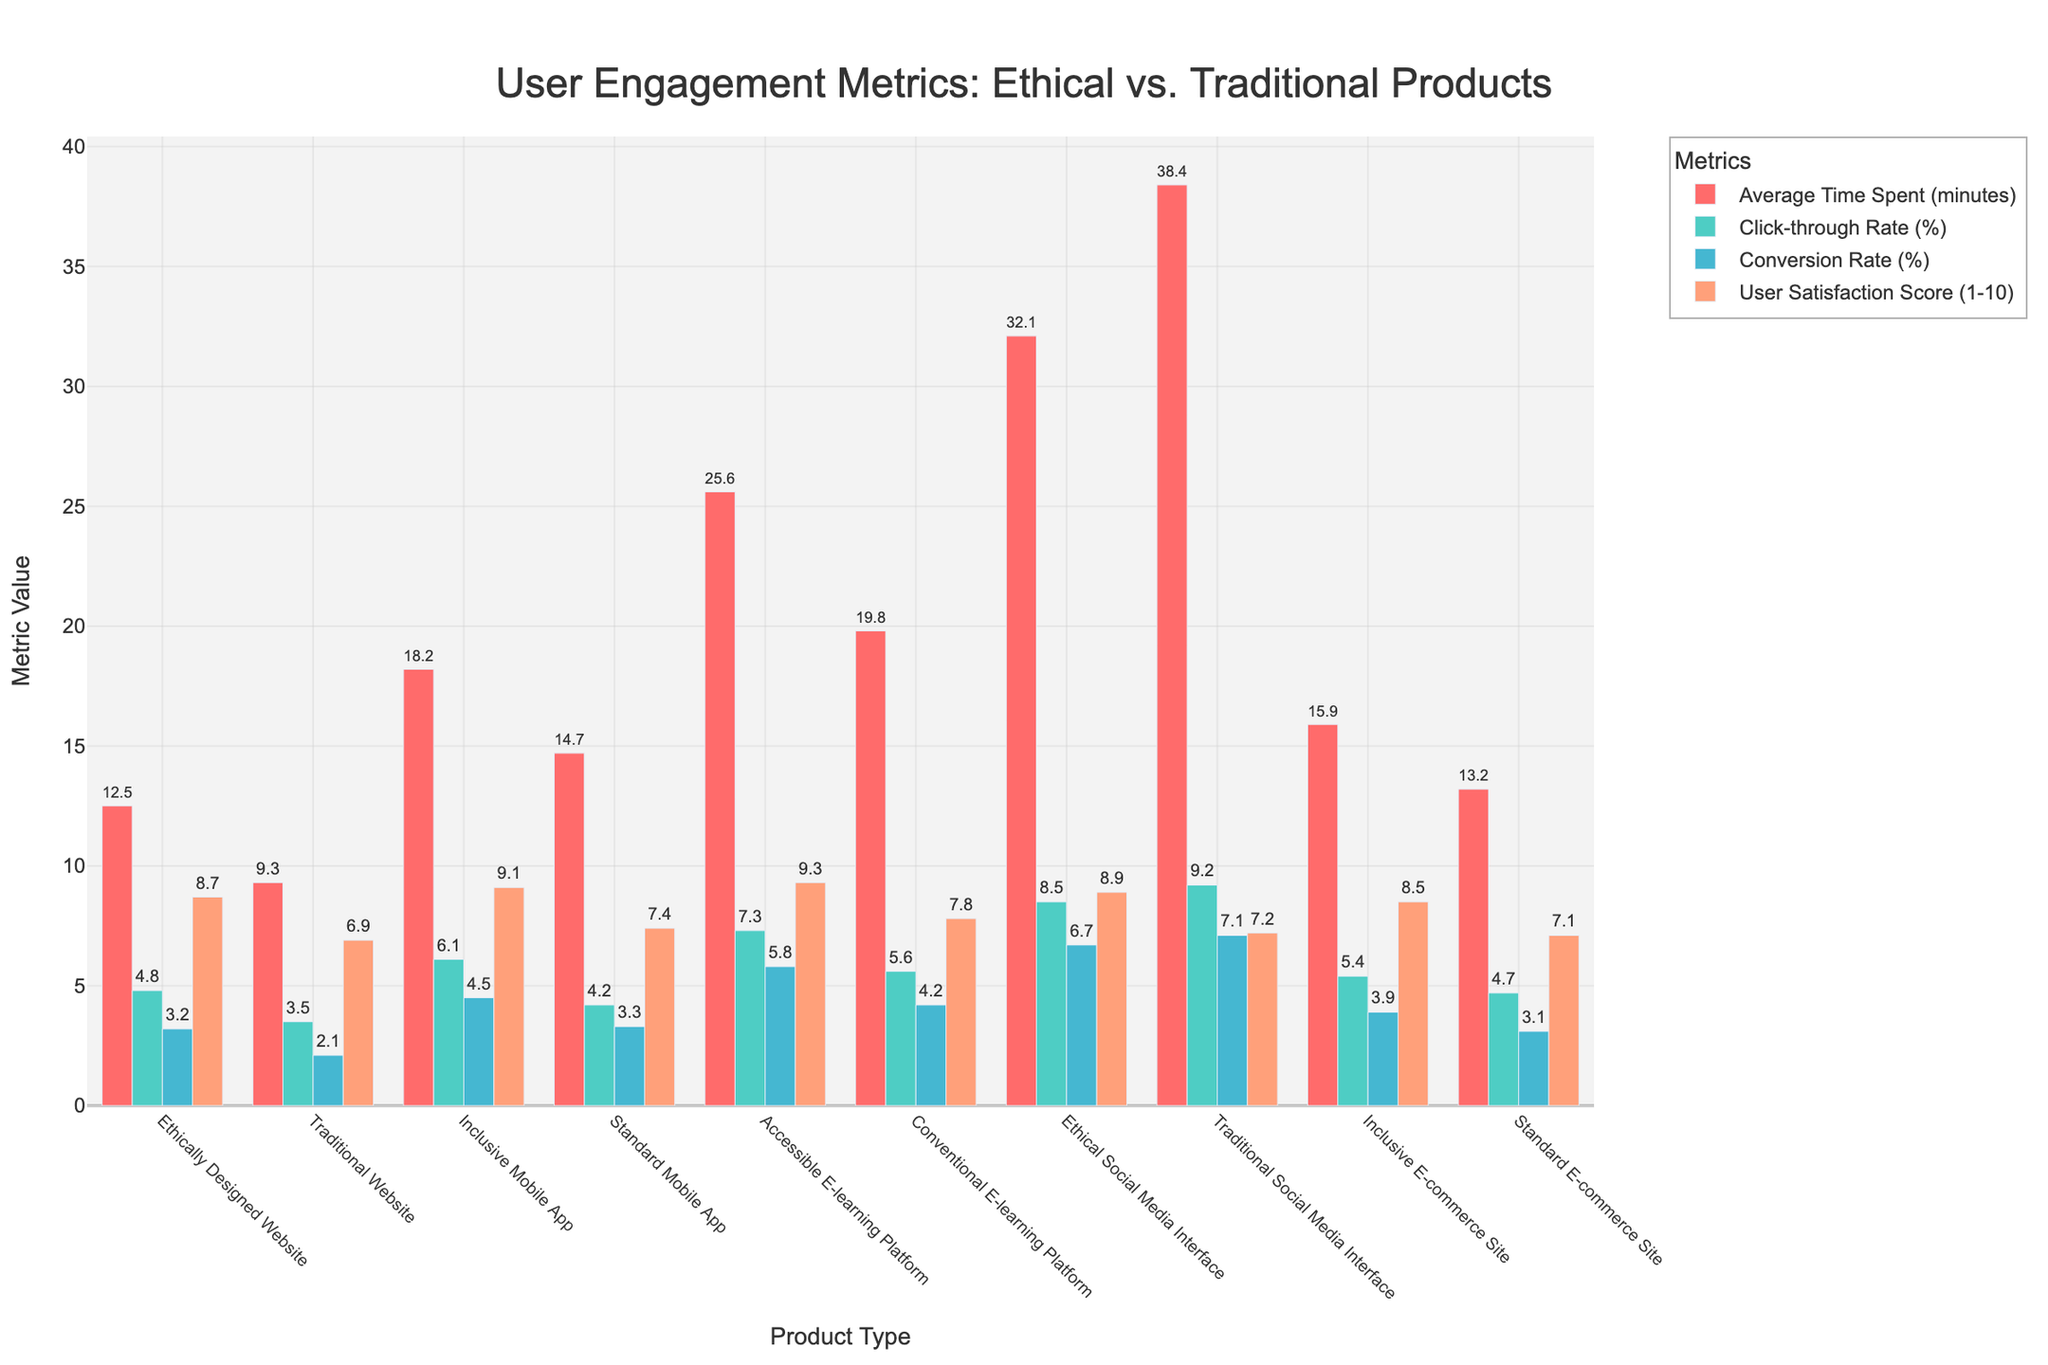Which product type has the highest average time spent? The bar for the Traditional Social Media Interface is the tallest in the "Average Time Spent (minutes)" category, indicating it has the highest value.
Answer: Traditional Social Media Interface What is the difference in average time spent between the Inclusive Mobile App and the Standard Mobile App? The Inclusive Mobile App has 18.2 minutes on average, while the Standard Mobile App has 14.7 minutes. The difference is 18.2 - 14.7 = 3.5.
Answer: 3.5 minutes How do the click-through rates compare between the Ethical Social Media Interface and the Traditional Social Media Interface? The Click-through Rate for the Ethical Social Media Interface is 8.5%, while for the Traditional Social Media Interface, it is 9.2%. Therefore, the Traditional Social Media Interface has a higher click-through rate by 0.7%.
Answer: Traditional Social Media Interface is higher by 0.7% Which product type has the lowest user satisfaction score, and what is the value? The bar for the Traditional Website in the "User Satisfaction Score" category is the shortest, indicating it has the lowest score of 6.9.
Answer: Traditional Website, 6.9 What is the sum of the conversion rates for the Accessible E-learning Platform and the Conventional E-learning Platform? The Accessible E-learning Platform has a conversion rate of 5.8%, while the Conventional E-learning Platform has a rate of 4.2%. Summing these values gives 5.8 + 4.2 = 10.
Answer: 10% How does the user satisfaction score of the Inclusive E-commerce Site compare to that of the Standard E-commerce Site? The User Satisfaction Score for the Inclusive E-commerce Site is 8.5, whereas the Standard E-commerce Site has a score of 7.1. The Inclusive E-commerce Site has a higher satisfaction score by 1.4 points.
Answer: Inclusive E-commerce Site is higher by 1.4 Which product type shows a higher conversion rate, the Ethical Social Media Interface or the Traditional Social Media Interface? The bar for Conversion Rate shows the values are 6.7% for the Ethical Social Media Interface and 7.1% for the Traditional Social Media Interface, so the Traditional Social Media Interface has a higher conversion rate.
Answer: Traditional Social Media Interface What is the average click-through rate for all the product types combined? The average click-through rate is the sum of all click-through rates divided by the number of product types. The sum is 4.8 + 3.5 + 6.1 + 4.2 + 7.3 + 5.6 + 8.5 + 9.2 + 5.4 + 4.7 = 59.3. There are 10 product types, so the average is 59.3 / 10 = 5.93.
Answer: 5.93% What is the total user satisfaction score for all ethically and inclusively designed products? Sum the User Satisfaction Scores of the Ethically Designed Website, Inclusive Mobile App, Accessible E-learning Platform, Ethical Social Media Interface, and Inclusive E-commerce Site: 8.7 + 9.1 + 9.3 + 8.9 + 8.5 = 44.5.
Answer: 44.5 